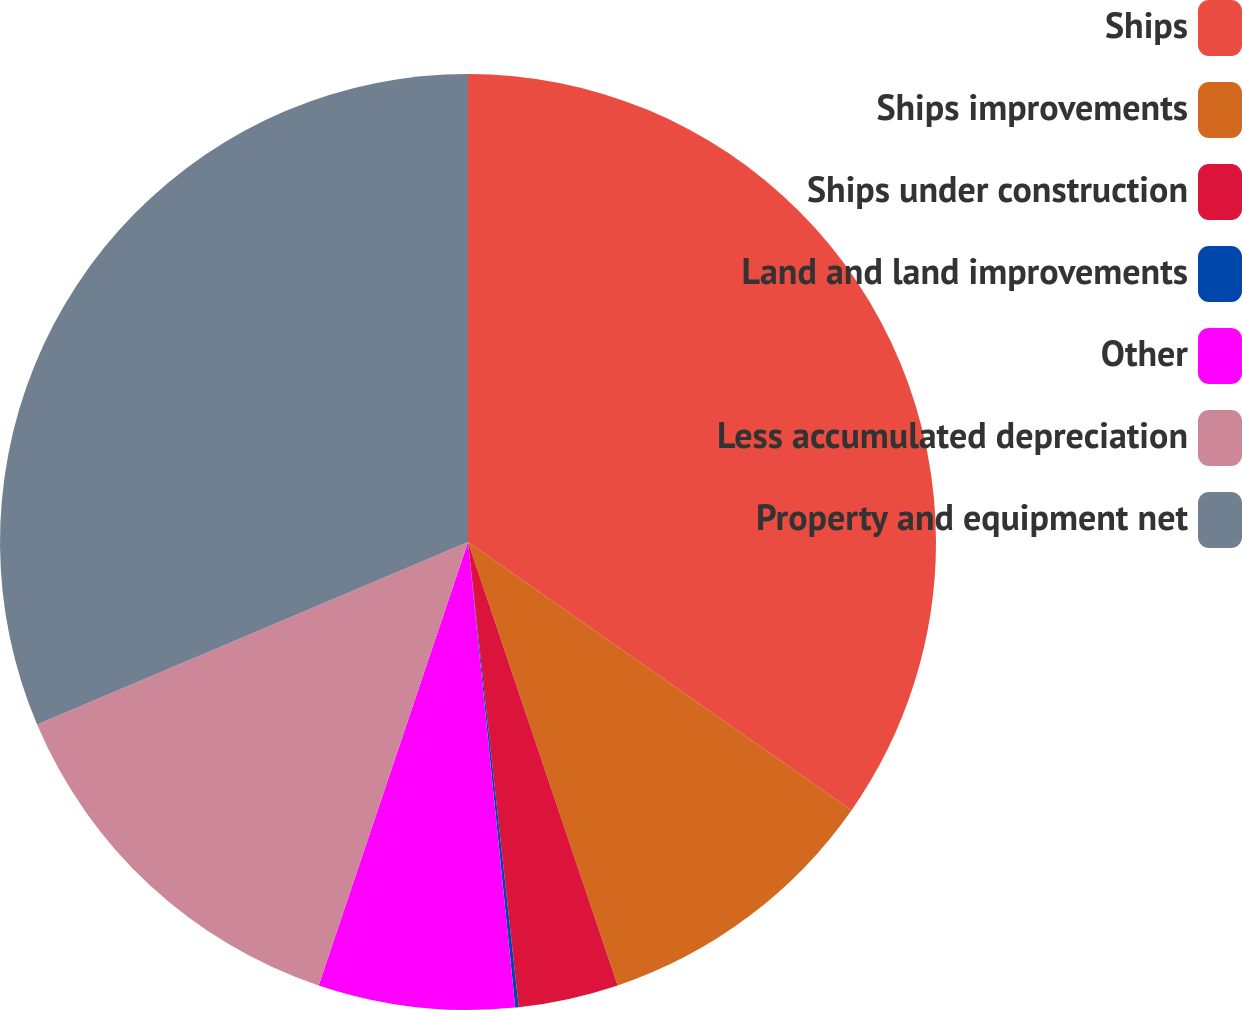Convert chart to OTSL. <chart><loc_0><loc_0><loc_500><loc_500><pie_chart><fcel>Ships<fcel>Ships improvements<fcel>Ships under construction<fcel>Land and land improvements<fcel>Other<fcel>Less accumulated depreciation<fcel>Property and equipment net<nl><fcel>34.71%<fcel>10.11%<fcel>3.45%<fcel>0.12%<fcel>6.78%<fcel>13.45%<fcel>31.38%<nl></chart> 